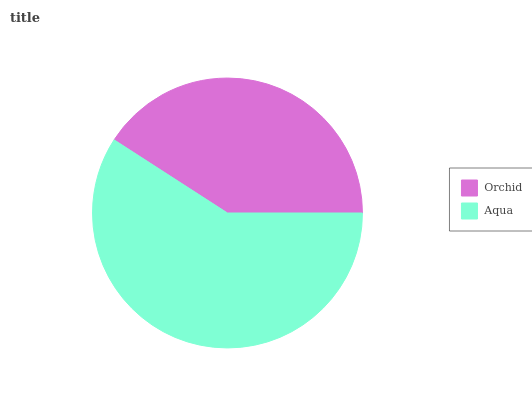Is Orchid the minimum?
Answer yes or no. Yes. Is Aqua the maximum?
Answer yes or no. Yes. Is Aqua the minimum?
Answer yes or no. No. Is Aqua greater than Orchid?
Answer yes or no. Yes. Is Orchid less than Aqua?
Answer yes or no. Yes. Is Orchid greater than Aqua?
Answer yes or no. No. Is Aqua less than Orchid?
Answer yes or no. No. Is Aqua the high median?
Answer yes or no. Yes. Is Orchid the low median?
Answer yes or no. Yes. Is Orchid the high median?
Answer yes or no. No. Is Aqua the low median?
Answer yes or no. No. 